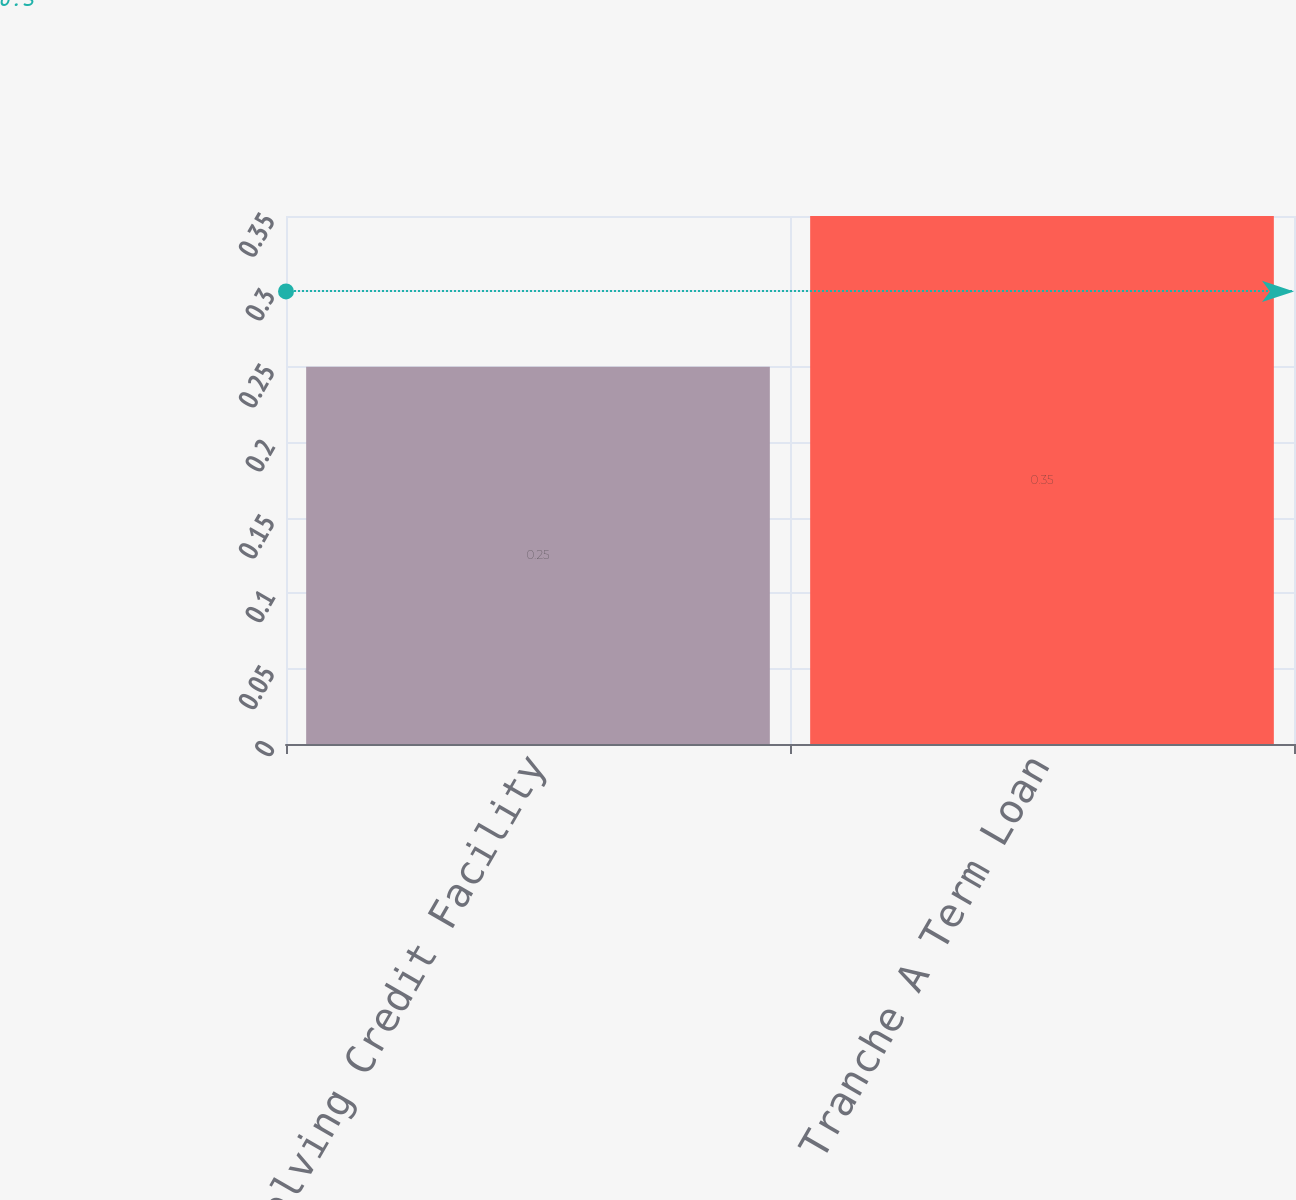Convert chart. <chart><loc_0><loc_0><loc_500><loc_500><bar_chart><fcel>Revolving Credit Facility<fcel>Tranche A Term Loan<nl><fcel>0.25<fcel>0.35<nl></chart> 